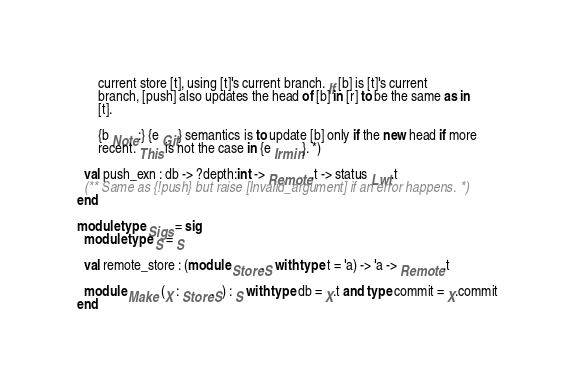Convert code to text. <code><loc_0><loc_0><loc_500><loc_500><_OCaml_>      current store [t], using [t]'s current branch. If [b] is [t]'s current
      branch, [push] also updates the head of [b] in [r] to be the same as in
      [t].

      {b Note:} {e Git} semantics is to update [b] only if the new head if more
      recent. This is not the case in {e Irmin}. *)

  val push_exn : db -> ?depth:int -> Remote.t -> status Lwt.t
  (** Same as {!push} but raise [Invalid_argument] if an error happens. *)
end

module type Sigs = sig
  module type S = S

  val remote_store : (module Store.S with type t = 'a) -> 'a -> Remote.t

  module Make (X : Store.S) : S with type db = X.t and type commit = X.commit
end
</code> 